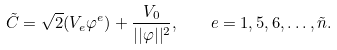Convert formula to latex. <formula><loc_0><loc_0><loc_500><loc_500>\tilde { C } = \sqrt { 2 } ( V _ { e } \varphi ^ { e } ) + \frac { V _ { 0 } } { | | \varphi | | ^ { 2 } } , \quad e = 1 , 5 , 6 , \dots , \tilde { n } .</formula> 